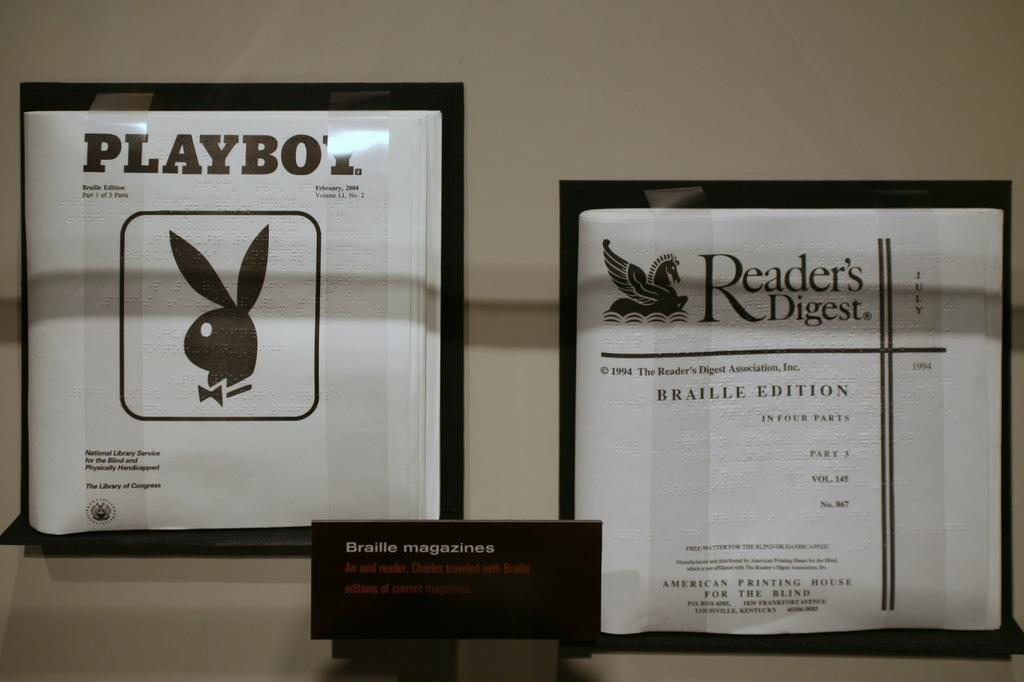What are the two white objects in the image? Unfortunately, the facts provided do not specify what the two white objects are. What is the surface visible at the back of the image? The facts provided do not give any information about the surface visible at the back of the image. How many stockings are hanging on the silver rack in the image? There is no mention of stockings or a silver rack in the provided facts, so we cannot answer this question. 